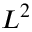<formula> <loc_0><loc_0><loc_500><loc_500>L ^ { 2 }</formula> 